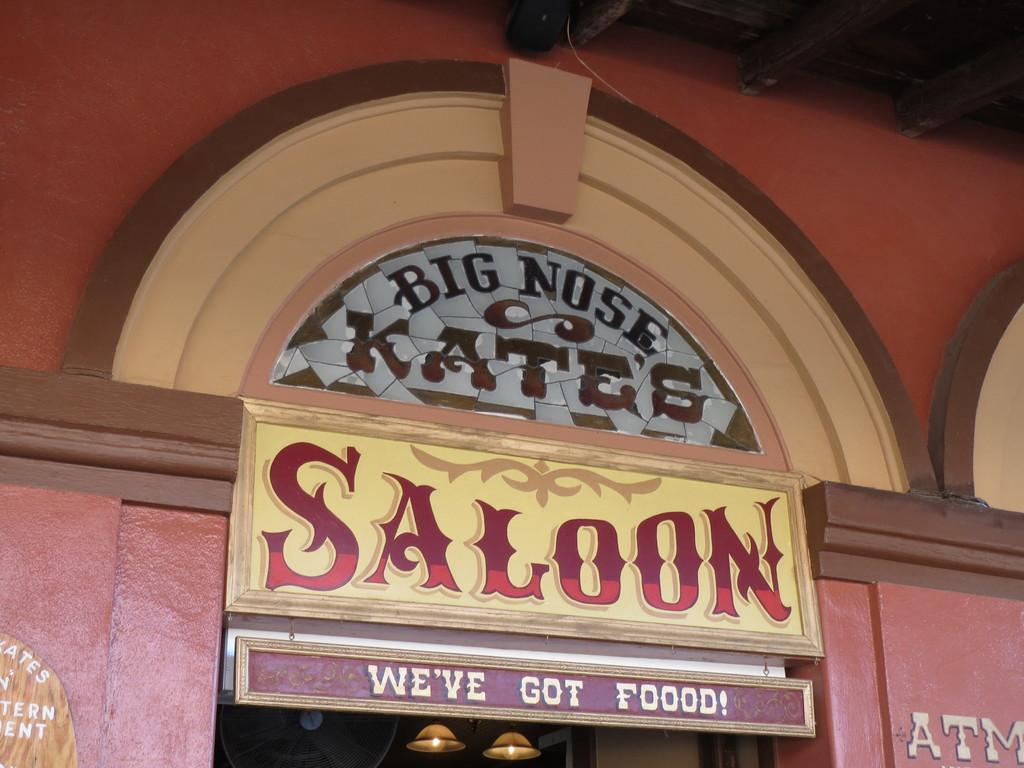What type of structure is depicted in the image? The image shows a building. What color is the building? The building is red. What is written on the board on the building? The word "saloon" is written on the board. How many lights are visible in the image? There are two lights visible in the image. What type of skirt is hanging on the wall in the image? There is no skirt present in the image. How many clovers are growing on the roof of the building? There are no clovers visible on the building in the image. 